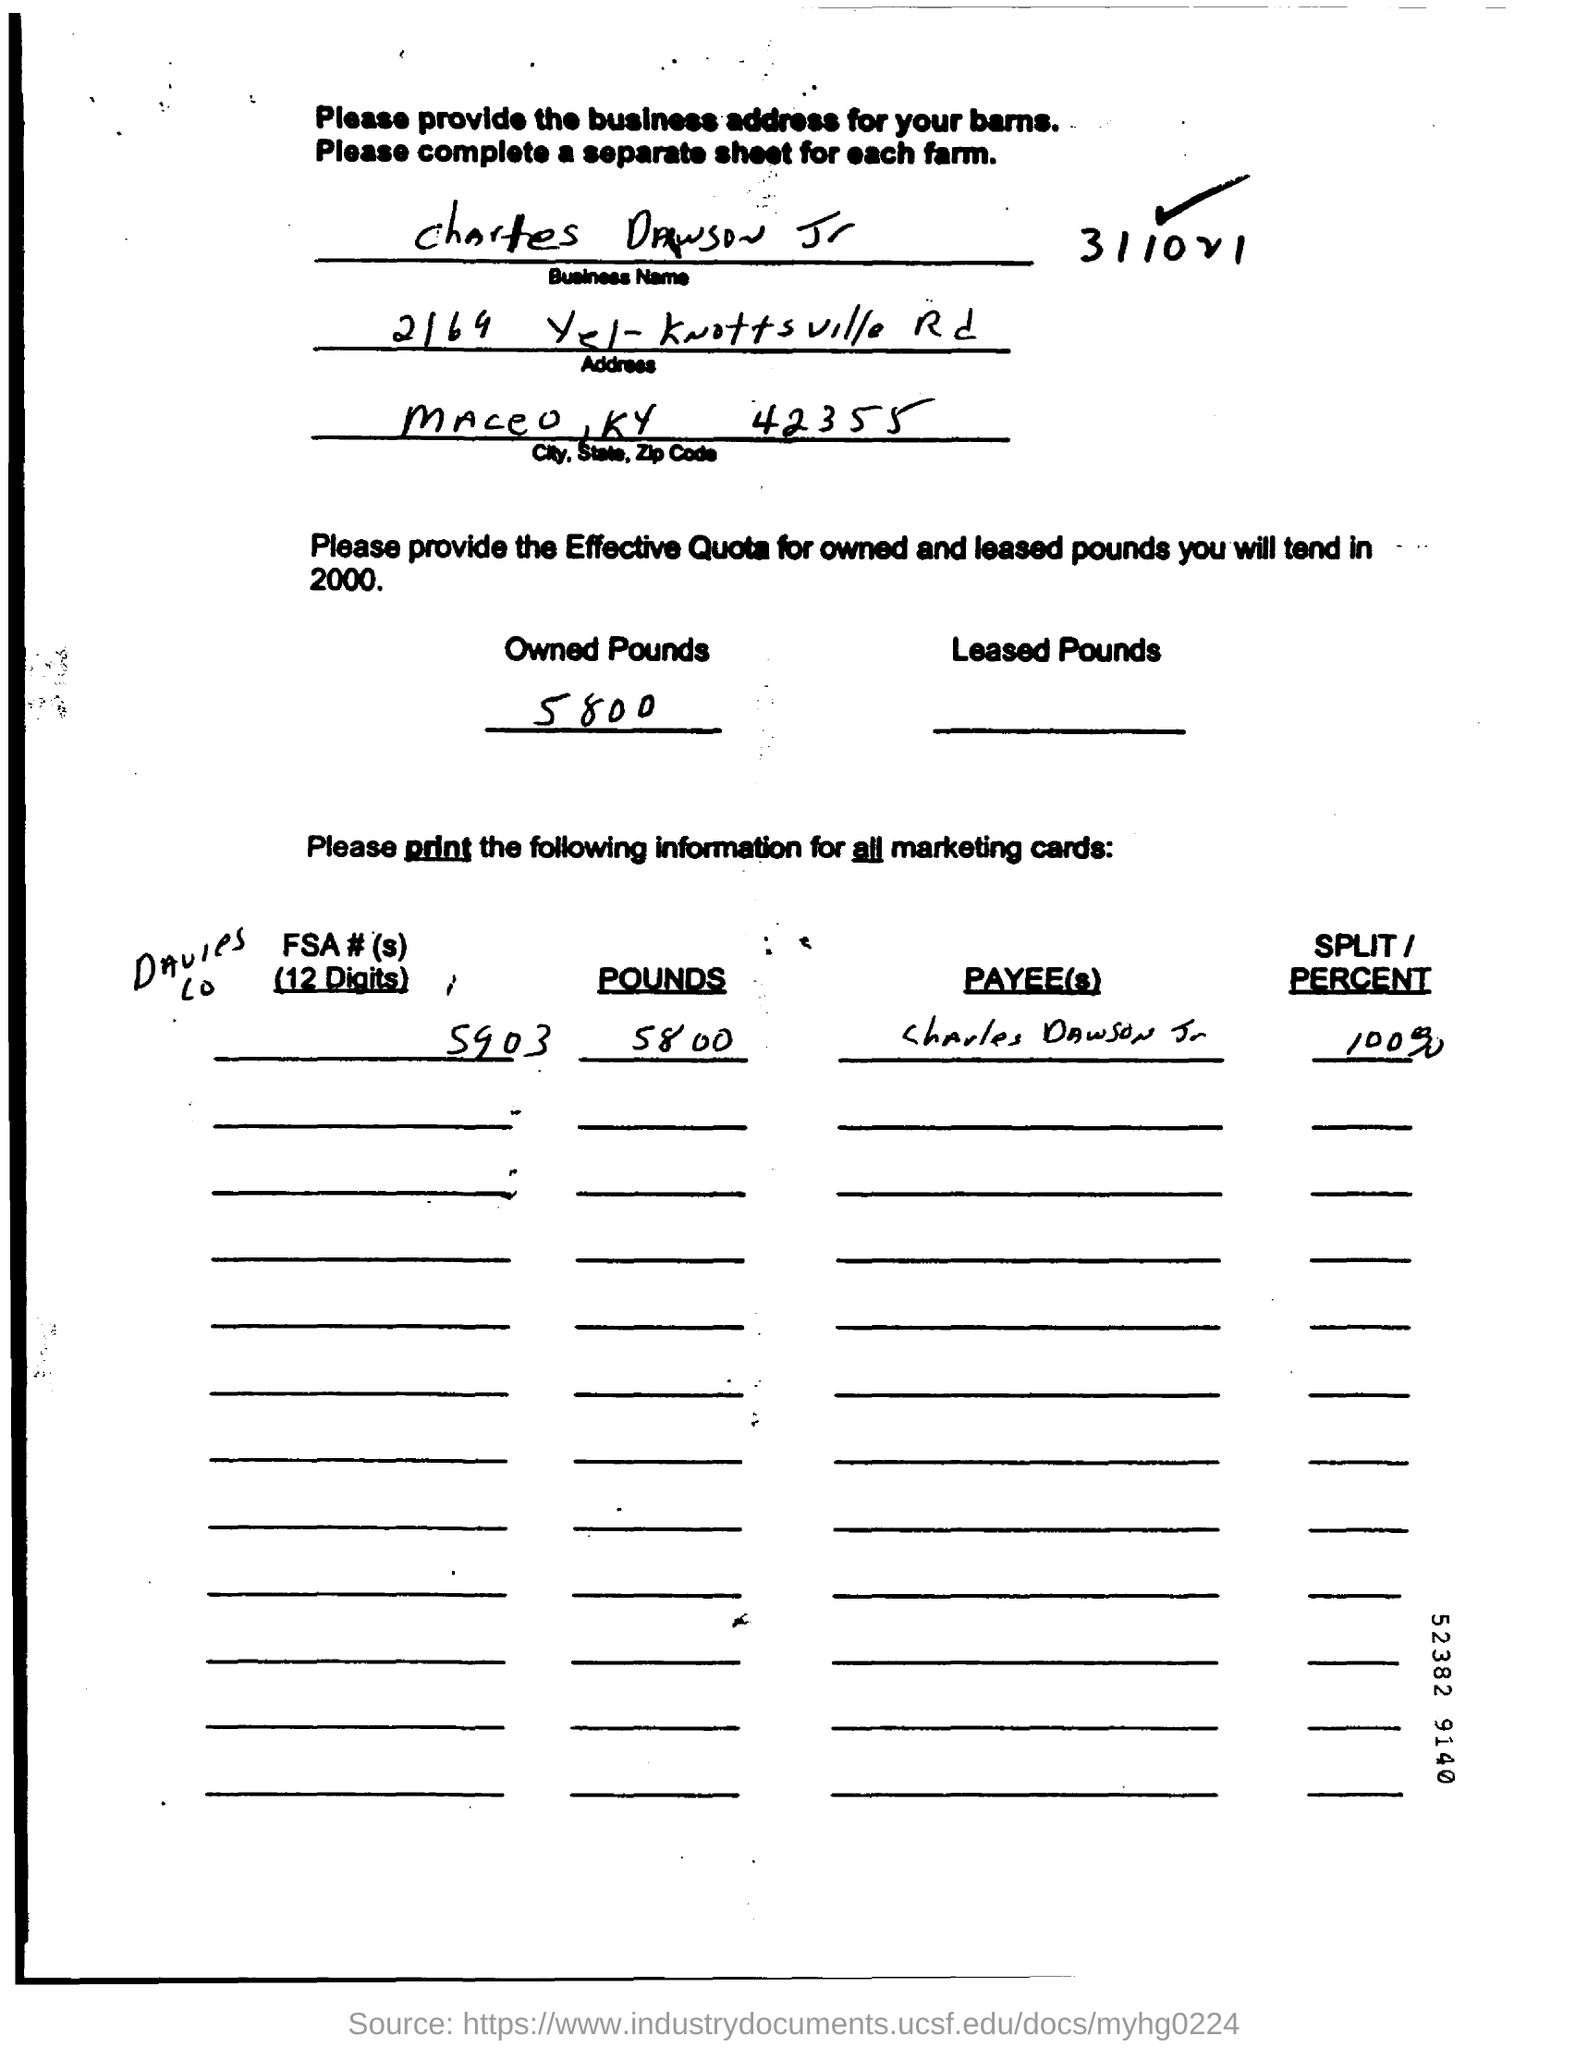What is the business name of the person given in the document?
Ensure brevity in your answer.  Charles Dawson Jr. What is the effective quota for owned pounds in 2000?
Ensure brevity in your answer.  5800. 